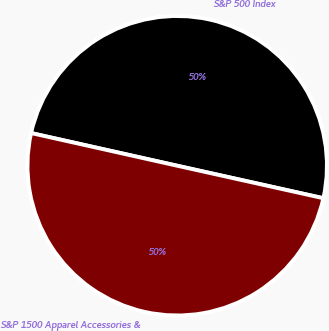<chart> <loc_0><loc_0><loc_500><loc_500><pie_chart><fcel>S&P 500 Index<fcel>S&P 1500 Apparel Accessories &<nl><fcel>49.98%<fcel>50.02%<nl></chart> 